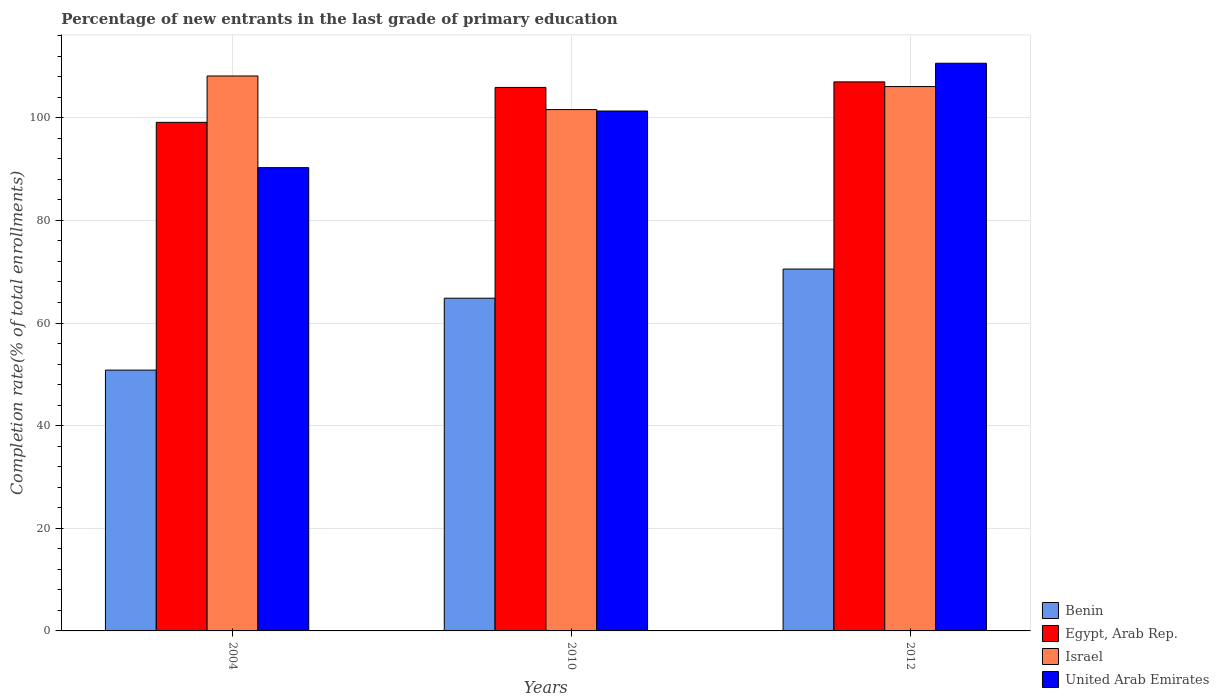How many different coloured bars are there?
Your response must be concise. 4. Are the number of bars on each tick of the X-axis equal?
Give a very brief answer. Yes. How many bars are there on the 1st tick from the right?
Your answer should be compact. 4. In how many cases, is the number of bars for a given year not equal to the number of legend labels?
Your answer should be very brief. 0. What is the percentage of new entrants in Benin in 2012?
Offer a very short reply. 70.52. Across all years, what is the maximum percentage of new entrants in Israel?
Your answer should be very brief. 108.15. Across all years, what is the minimum percentage of new entrants in Egypt, Arab Rep.?
Offer a very short reply. 99.11. In which year was the percentage of new entrants in Benin maximum?
Your answer should be compact. 2012. In which year was the percentage of new entrants in Israel minimum?
Ensure brevity in your answer.  2010. What is the total percentage of new entrants in United Arab Emirates in the graph?
Provide a short and direct response. 302.23. What is the difference between the percentage of new entrants in Israel in 2004 and that in 2012?
Your answer should be compact. 2.06. What is the difference between the percentage of new entrants in United Arab Emirates in 2010 and the percentage of new entrants in Egypt, Arab Rep. in 2004?
Keep it short and to the point. 2.21. What is the average percentage of new entrants in Benin per year?
Make the answer very short. 62.06. In the year 2012, what is the difference between the percentage of new entrants in Egypt, Arab Rep. and percentage of new entrants in Benin?
Your response must be concise. 36.48. What is the ratio of the percentage of new entrants in Benin in 2004 to that in 2010?
Provide a short and direct response. 0.78. What is the difference between the highest and the second highest percentage of new entrants in Israel?
Keep it short and to the point. 2.06. What is the difference between the highest and the lowest percentage of new entrants in United Arab Emirates?
Ensure brevity in your answer.  20.34. In how many years, is the percentage of new entrants in Israel greater than the average percentage of new entrants in Israel taken over all years?
Your response must be concise. 2. What does the 1st bar from the left in 2004 represents?
Your response must be concise. Benin. What does the 1st bar from the right in 2004 represents?
Keep it short and to the point. United Arab Emirates. How many years are there in the graph?
Your answer should be compact. 3. Are the values on the major ticks of Y-axis written in scientific E-notation?
Offer a terse response. No. How many legend labels are there?
Your answer should be compact. 4. How are the legend labels stacked?
Keep it short and to the point. Vertical. What is the title of the graph?
Provide a succinct answer. Percentage of new entrants in the last grade of primary education. What is the label or title of the X-axis?
Your answer should be compact. Years. What is the label or title of the Y-axis?
Your response must be concise. Completion rate(% of total enrollments). What is the Completion rate(% of total enrollments) of Benin in 2004?
Your response must be concise. 50.82. What is the Completion rate(% of total enrollments) of Egypt, Arab Rep. in 2004?
Provide a succinct answer. 99.11. What is the Completion rate(% of total enrollments) in Israel in 2004?
Keep it short and to the point. 108.15. What is the Completion rate(% of total enrollments) of United Arab Emirates in 2004?
Your answer should be very brief. 90.28. What is the Completion rate(% of total enrollments) in Benin in 2010?
Make the answer very short. 64.84. What is the Completion rate(% of total enrollments) of Egypt, Arab Rep. in 2010?
Keep it short and to the point. 105.91. What is the Completion rate(% of total enrollments) in Israel in 2010?
Ensure brevity in your answer.  101.6. What is the Completion rate(% of total enrollments) of United Arab Emirates in 2010?
Ensure brevity in your answer.  101.32. What is the Completion rate(% of total enrollments) in Benin in 2012?
Offer a very short reply. 70.52. What is the Completion rate(% of total enrollments) of Egypt, Arab Rep. in 2012?
Ensure brevity in your answer.  107. What is the Completion rate(% of total enrollments) in Israel in 2012?
Ensure brevity in your answer.  106.08. What is the Completion rate(% of total enrollments) of United Arab Emirates in 2012?
Ensure brevity in your answer.  110.63. Across all years, what is the maximum Completion rate(% of total enrollments) of Benin?
Provide a short and direct response. 70.52. Across all years, what is the maximum Completion rate(% of total enrollments) of Egypt, Arab Rep.?
Make the answer very short. 107. Across all years, what is the maximum Completion rate(% of total enrollments) in Israel?
Keep it short and to the point. 108.15. Across all years, what is the maximum Completion rate(% of total enrollments) of United Arab Emirates?
Provide a succinct answer. 110.63. Across all years, what is the minimum Completion rate(% of total enrollments) of Benin?
Your response must be concise. 50.82. Across all years, what is the minimum Completion rate(% of total enrollments) of Egypt, Arab Rep.?
Offer a very short reply. 99.11. Across all years, what is the minimum Completion rate(% of total enrollments) of Israel?
Your answer should be compact. 101.6. Across all years, what is the minimum Completion rate(% of total enrollments) in United Arab Emirates?
Ensure brevity in your answer.  90.28. What is the total Completion rate(% of total enrollments) in Benin in the graph?
Make the answer very short. 186.19. What is the total Completion rate(% of total enrollments) of Egypt, Arab Rep. in the graph?
Offer a terse response. 312.02. What is the total Completion rate(% of total enrollments) in Israel in the graph?
Your response must be concise. 315.83. What is the total Completion rate(% of total enrollments) of United Arab Emirates in the graph?
Your response must be concise. 302.23. What is the difference between the Completion rate(% of total enrollments) of Benin in 2004 and that in 2010?
Keep it short and to the point. -14.02. What is the difference between the Completion rate(% of total enrollments) of Egypt, Arab Rep. in 2004 and that in 2010?
Keep it short and to the point. -6.8. What is the difference between the Completion rate(% of total enrollments) in Israel in 2004 and that in 2010?
Provide a short and direct response. 6.55. What is the difference between the Completion rate(% of total enrollments) in United Arab Emirates in 2004 and that in 2010?
Your answer should be very brief. -11.04. What is the difference between the Completion rate(% of total enrollments) in Benin in 2004 and that in 2012?
Your response must be concise. -19.7. What is the difference between the Completion rate(% of total enrollments) in Egypt, Arab Rep. in 2004 and that in 2012?
Keep it short and to the point. -7.89. What is the difference between the Completion rate(% of total enrollments) in Israel in 2004 and that in 2012?
Your answer should be compact. 2.06. What is the difference between the Completion rate(% of total enrollments) in United Arab Emirates in 2004 and that in 2012?
Provide a succinct answer. -20.34. What is the difference between the Completion rate(% of total enrollments) in Benin in 2010 and that in 2012?
Keep it short and to the point. -5.68. What is the difference between the Completion rate(% of total enrollments) of Egypt, Arab Rep. in 2010 and that in 2012?
Your response must be concise. -1.08. What is the difference between the Completion rate(% of total enrollments) in Israel in 2010 and that in 2012?
Keep it short and to the point. -4.49. What is the difference between the Completion rate(% of total enrollments) of United Arab Emirates in 2010 and that in 2012?
Keep it short and to the point. -9.31. What is the difference between the Completion rate(% of total enrollments) in Benin in 2004 and the Completion rate(% of total enrollments) in Egypt, Arab Rep. in 2010?
Ensure brevity in your answer.  -55.09. What is the difference between the Completion rate(% of total enrollments) of Benin in 2004 and the Completion rate(% of total enrollments) of Israel in 2010?
Provide a short and direct response. -50.77. What is the difference between the Completion rate(% of total enrollments) in Benin in 2004 and the Completion rate(% of total enrollments) in United Arab Emirates in 2010?
Ensure brevity in your answer.  -50.49. What is the difference between the Completion rate(% of total enrollments) of Egypt, Arab Rep. in 2004 and the Completion rate(% of total enrollments) of Israel in 2010?
Provide a short and direct response. -2.49. What is the difference between the Completion rate(% of total enrollments) of Egypt, Arab Rep. in 2004 and the Completion rate(% of total enrollments) of United Arab Emirates in 2010?
Your answer should be very brief. -2.21. What is the difference between the Completion rate(% of total enrollments) in Israel in 2004 and the Completion rate(% of total enrollments) in United Arab Emirates in 2010?
Give a very brief answer. 6.83. What is the difference between the Completion rate(% of total enrollments) in Benin in 2004 and the Completion rate(% of total enrollments) in Egypt, Arab Rep. in 2012?
Give a very brief answer. -56.17. What is the difference between the Completion rate(% of total enrollments) of Benin in 2004 and the Completion rate(% of total enrollments) of Israel in 2012?
Provide a short and direct response. -55.26. What is the difference between the Completion rate(% of total enrollments) in Benin in 2004 and the Completion rate(% of total enrollments) in United Arab Emirates in 2012?
Make the answer very short. -59.8. What is the difference between the Completion rate(% of total enrollments) of Egypt, Arab Rep. in 2004 and the Completion rate(% of total enrollments) of Israel in 2012?
Offer a terse response. -6.98. What is the difference between the Completion rate(% of total enrollments) of Egypt, Arab Rep. in 2004 and the Completion rate(% of total enrollments) of United Arab Emirates in 2012?
Provide a short and direct response. -11.52. What is the difference between the Completion rate(% of total enrollments) of Israel in 2004 and the Completion rate(% of total enrollments) of United Arab Emirates in 2012?
Your answer should be very brief. -2.48. What is the difference between the Completion rate(% of total enrollments) of Benin in 2010 and the Completion rate(% of total enrollments) of Egypt, Arab Rep. in 2012?
Make the answer very short. -42.16. What is the difference between the Completion rate(% of total enrollments) of Benin in 2010 and the Completion rate(% of total enrollments) of Israel in 2012?
Offer a very short reply. -41.24. What is the difference between the Completion rate(% of total enrollments) in Benin in 2010 and the Completion rate(% of total enrollments) in United Arab Emirates in 2012?
Your answer should be compact. -45.79. What is the difference between the Completion rate(% of total enrollments) in Egypt, Arab Rep. in 2010 and the Completion rate(% of total enrollments) in Israel in 2012?
Your answer should be very brief. -0.17. What is the difference between the Completion rate(% of total enrollments) in Egypt, Arab Rep. in 2010 and the Completion rate(% of total enrollments) in United Arab Emirates in 2012?
Your answer should be very brief. -4.71. What is the difference between the Completion rate(% of total enrollments) in Israel in 2010 and the Completion rate(% of total enrollments) in United Arab Emirates in 2012?
Provide a succinct answer. -9.03. What is the average Completion rate(% of total enrollments) of Benin per year?
Ensure brevity in your answer.  62.06. What is the average Completion rate(% of total enrollments) of Egypt, Arab Rep. per year?
Provide a short and direct response. 104.01. What is the average Completion rate(% of total enrollments) in Israel per year?
Provide a succinct answer. 105.28. What is the average Completion rate(% of total enrollments) of United Arab Emirates per year?
Make the answer very short. 100.74. In the year 2004, what is the difference between the Completion rate(% of total enrollments) in Benin and Completion rate(% of total enrollments) in Egypt, Arab Rep.?
Give a very brief answer. -48.28. In the year 2004, what is the difference between the Completion rate(% of total enrollments) of Benin and Completion rate(% of total enrollments) of Israel?
Your response must be concise. -57.32. In the year 2004, what is the difference between the Completion rate(% of total enrollments) of Benin and Completion rate(% of total enrollments) of United Arab Emirates?
Your response must be concise. -39.46. In the year 2004, what is the difference between the Completion rate(% of total enrollments) in Egypt, Arab Rep. and Completion rate(% of total enrollments) in Israel?
Provide a succinct answer. -9.04. In the year 2004, what is the difference between the Completion rate(% of total enrollments) of Egypt, Arab Rep. and Completion rate(% of total enrollments) of United Arab Emirates?
Provide a succinct answer. 8.83. In the year 2004, what is the difference between the Completion rate(% of total enrollments) of Israel and Completion rate(% of total enrollments) of United Arab Emirates?
Your answer should be compact. 17.86. In the year 2010, what is the difference between the Completion rate(% of total enrollments) in Benin and Completion rate(% of total enrollments) in Egypt, Arab Rep.?
Keep it short and to the point. -41.07. In the year 2010, what is the difference between the Completion rate(% of total enrollments) in Benin and Completion rate(% of total enrollments) in Israel?
Provide a succinct answer. -36.76. In the year 2010, what is the difference between the Completion rate(% of total enrollments) in Benin and Completion rate(% of total enrollments) in United Arab Emirates?
Your response must be concise. -36.48. In the year 2010, what is the difference between the Completion rate(% of total enrollments) in Egypt, Arab Rep. and Completion rate(% of total enrollments) in Israel?
Provide a short and direct response. 4.32. In the year 2010, what is the difference between the Completion rate(% of total enrollments) in Egypt, Arab Rep. and Completion rate(% of total enrollments) in United Arab Emirates?
Make the answer very short. 4.59. In the year 2010, what is the difference between the Completion rate(% of total enrollments) in Israel and Completion rate(% of total enrollments) in United Arab Emirates?
Your answer should be very brief. 0.28. In the year 2012, what is the difference between the Completion rate(% of total enrollments) of Benin and Completion rate(% of total enrollments) of Egypt, Arab Rep.?
Your answer should be very brief. -36.48. In the year 2012, what is the difference between the Completion rate(% of total enrollments) in Benin and Completion rate(% of total enrollments) in Israel?
Make the answer very short. -35.56. In the year 2012, what is the difference between the Completion rate(% of total enrollments) in Benin and Completion rate(% of total enrollments) in United Arab Emirates?
Your response must be concise. -40.1. In the year 2012, what is the difference between the Completion rate(% of total enrollments) of Egypt, Arab Rep. and Completion rate(% of total enrollments) of Israel?
Keep it short and to the point. 0.91. In the year 2012, what is the difference between the Completion rate(% of total enrollments) of Egypt, Arab Rep. and Completion rate(% of total enrollments) of United Arab Emirates?
Provide a short and direct response. -3.63. In the year 2012, what is the difference between the Completion rate(% of total enrollments) in Israel and Completion rate(% of total enrollments) in United Arab Emirates?
Offer a terse response. -4.54. What is the ratio of the Completion rate(% of total enrollments) of Benin in 2004 to that in 2010?
Keep it short and to the point. 0.78. What is the ratio of the Completion rate(% of total enrollments) of Egypt, Arab Rep. in 2004 to that in 2010?
Offer a terse response. 0.94. What is the ratio of the Completion rate(% of total enrollments) in Israel in 2004 to that in 2010?
Provide a short and direct response. 1.06. What is the ratio of the Completion rate(% of total enrollments) of United Arab Emirates in 2004 to that in 2010?
Your answer should be compact. 0.89. What is the ratio of the Completion rate(% of total enrollments) of Benin in 2004 to that in 2012?
Provide a succinct answer. 0.72. What is the ratio of the Completion rate(% of total enrollments) of Egypt, Arab Rep. in 2004 to that in 2012?
Offer a terse response. 0.93. What is the ratio of the Completion rate(% of total enrollments) in Israel in 2004 to that in 2012?
Give a very brief answer. 1.02. What is the ratio of the Completion rate(% of total enrollments) of United Arab Emirates in 2004 to that in 2012?
Provide a short and direct response. 0.82. What is the ratio of the Completion rate(% of total enrollments) of Benin in 2010 to that in 2012?
Give a very brief answer. 0.92. What is the ratio of the Completion rate(% of total enrollments) of Egypt, Arab Rep. in 2010 to that in 2012?
Ensure brevity in your answer.  0.99. What is the ratio of the Completion rate(% of total enrollments) of Israel in 2010 to that in 2012?
Your response must be concise. 0.96. What is the ratio of the Completion rate(% of total enrollments) of United Arab Emirates in 2010 to that in 2012?
Ensure brevity in your answer.  0.92. What is the difference between the highest and the second highest Completion rate(% of total enrollments) of Benin?
Keep it short and to the point. 5.68. What is the difference between the highest and the second highest Completion rate(% of total enrollments) of Egypt, Arab Rep.?
Provide a short and direct response. 1.08. What is the difference between the highest and the second highest Completion rate(% of total enrollments) of Israel?
Your answer should be very brief. 2.06. What is the difference between the highest and the second highest Completion rate(% of total enrollments) of United Arab Emirates?
Provide a succinct answer. 9.31. What is the difference between the highest and the lowest Completion rate(% of total enrollments) of Benin?
Keep it short and to the point. 19.7. What is the difference between the highest and the lowest Completion rate(% of total enrollments) of Egypt, Arab Rep.?
Your response must be concise. 7.89. What is the difference between the highest and the lowest Completion rate(% of total enrollments) in Israel?
Keep it short and to the point. 6.55. What is the difference between the highest and the lowest Completion rate(% of total enrollments) in United Arab Emirates?
Provide a short and direct response. 20.34. 